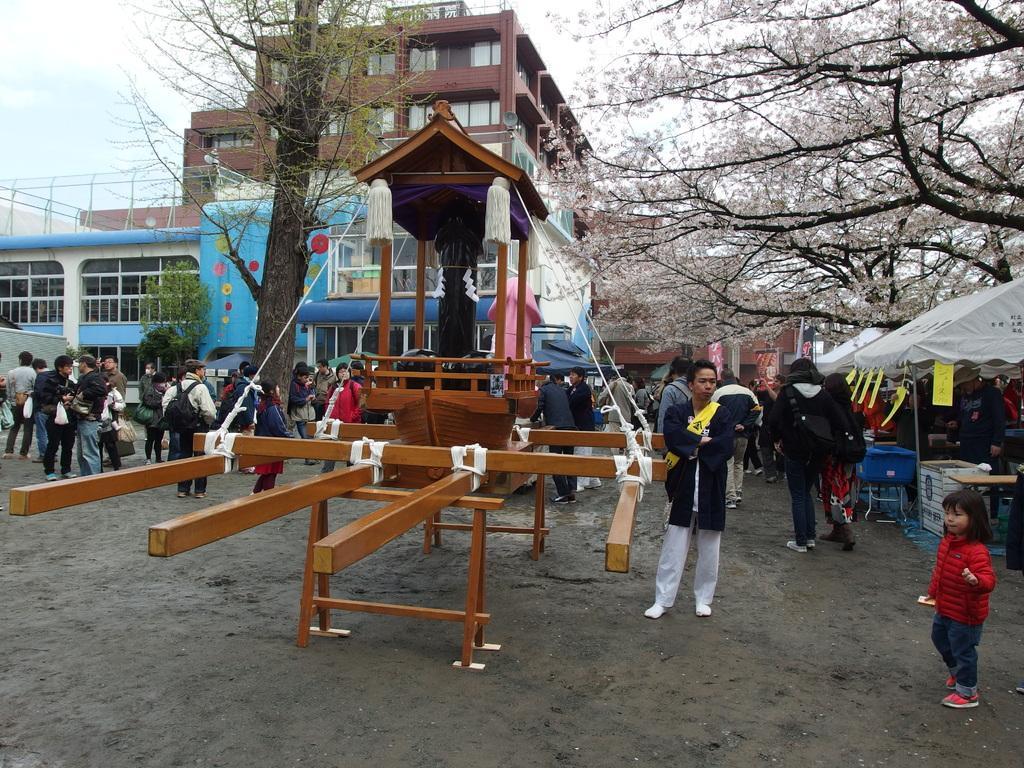In one or two sentences, can you explain what this image depicts? In this image there is a building at left side of this image and there is a tree at middle of this image and right side of the image as well. there are some persons standing as we can see in middle of this image, and there is one object which is in red color is placed at middle of this image. The person standing at right side is wearing black color shirt and white color pant, and there is one girl is standing at bottom right corner of this image is wearing red color dress and there are some shops at right side of this image. 